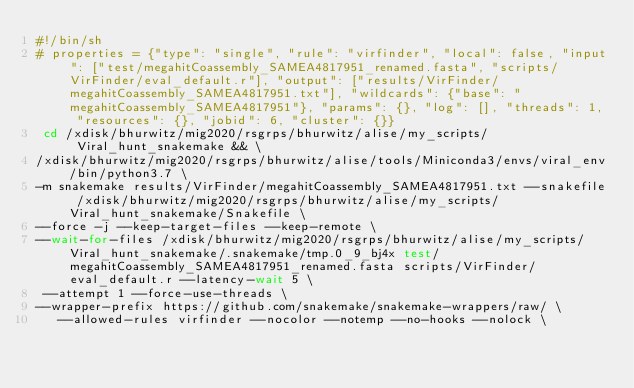Convert code to text. <code><loc_0><loc_0><loc_500><loc_500><_Bash_>#!/bin/sh
# properties = {"type": "single", "rule": "virfinder", "local": false, "input": ["test/megahitCoassembly_SAMEA4817951_renamed.fasta", "scripts/VirFinder/eval_default.r"], "output": ["results/VirFinder/megahitCoassembly_SAMEA4817951.txt"], "wildcards": {"base": "megahitCoassembly_SAMEA4817951"}, "params": {}, "log": [], "threads": 1, "resources": {}, "jobid": 6, "cluster": {}}
 cd /xdisk/bhurwitz/mig2020/rsgrps/bhurwitz/alise/my_scripts/Viral_hunt_snakemake && \
/xdisk/bhurwitz/mig2020/rsgrps/bhurwitz/alise/tools/Miniconda3/envs/viral_env/bin/python3.7 \
-m snakemake results/VirFinder/megahitCoassembly_SAMEA4817951.txt --snakefile /xdisk/bhurwitz/mig2020/rsgrps/bhurwitz/alise/my_scripts/Viral_hunt_snakemake/Snakefile \
--force -j --keep-target-files --keep-remote \
--wait-for-files /xdisk/bhurwitz/mig2020/rsgrps/bhurwitz/alise/my_scripts/Viral_hunt_snakemake/.snakemake/tmp.0_9_bj4x test/megahitCoassembly_SAMEA4817951_renamed.fasta scripts/VirFinder/eval_default.r --latency-wait 5 \
 --attempt 1 --force-use-threads \
--wrapper-prefix https://github.com/snakemake/snakemake-wrappers/raw/ \
   --allowed-rules virfinder --nocolor --notemp --no-hooks --nolock \</code> 